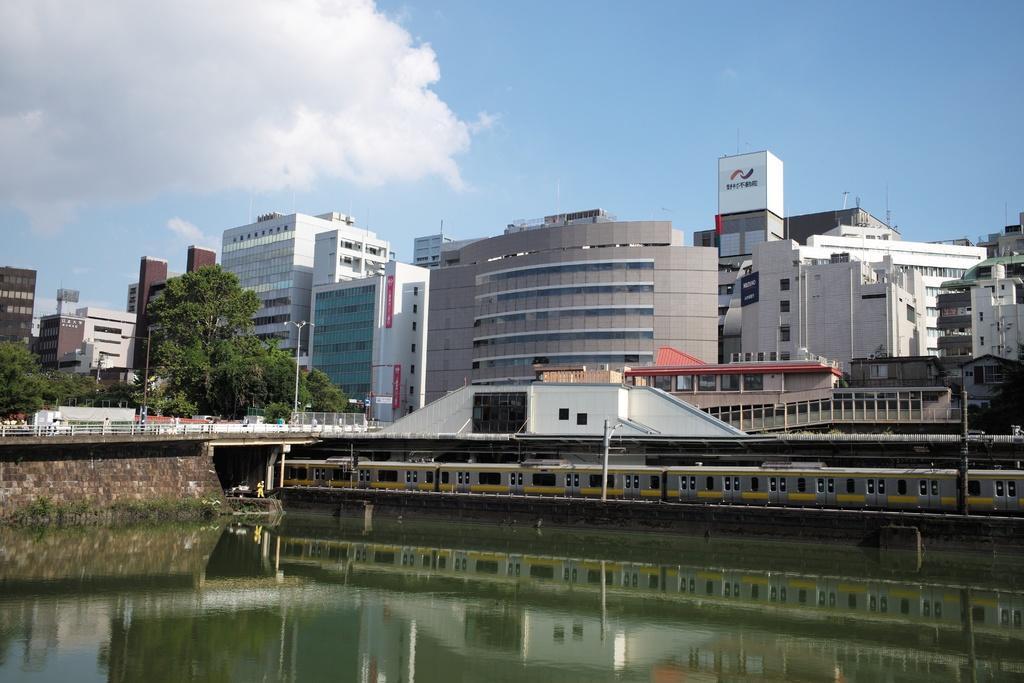Could you give a brief overview of what you see in this image? In the picture I can see the water, a train moving on the railway track, I can see the bridge, poles, light poles, buildings, trees and the sky with clouds in the background. 